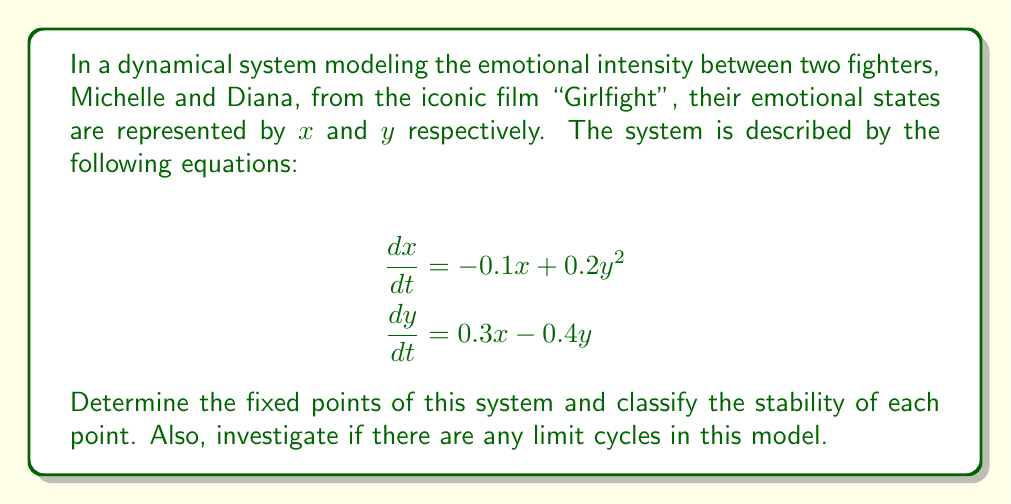Could you help me with this problem? Step 1: Find the fixed points
To find the fixed points, set both equations equal to zero:

$$-0.1x + 0.2y^2 = 0$$
$$0.3x - 0.4y = 0$$

From the second equation:
$$x = \frac{4y}{3}$$

Substituting this into the first equation:
$$-0.1(\frac{4y}{3}) + 0.2y^2 = 0$$
$$-\frac{4y}{30} + 0.2y^2 = 0$$
$$0.2y^2 - \frac{2y}{15} = 0$$
$$y(0.2y - \frac{2}{15}) = 0$$

Solving this, we get $y = 0$ or $y = \frac{1}{15}$

When $y = 0$, $x = 0$
When $y = \frac{1}{15}$, $x = \frac{4}{45}$

So, the fixed points are $(0,0)$ and $(\frac{4}{45}, \frac{1}{15})$

Step 2: Classify the stability of fixed points
To determine stability, we need to find the Jacobian matrix:

$$J = \begin{bmatrix}
\frac{\partial f_1}{\partial x} & \frac{\partial f_1}{\partial y} \\
\frac{\partial f_2}{\partial x} & \frac{\partial f_2}{\partial y}
\end{bmatrix} = \begin{bmatrix}
-0.1 & 0.4y \\
0.3 & -0.4
\end{bmatrix}$$

For $(0,0)$:
$$J_{(0,0)} = \begin{bmatrix}
-0.1 & 0 \\
0.3 & -0.4
\end{bmatrix}$$

The eigenvalues are $\lambda_1 = -0.1$ and $\lambda_2 = -0.4$. Both are negative, so $(0,0)$ is a stable node.

For $(\frac{4}{45}, \frac{1}{15})$:
$$J_{(\frac{4}{45}, \frac{1}{15})} = \begin{bmatrix}
-0.1 & 0.4(\frac{1}{15}) \\
0.3 & -0.4
\end{bmatrix} = \begin{bmatrix}
-0.1 & \frac{2}{75} \\
0.3 & -0.4
\end{bmatrix}$$

The eigenvalues are complex conjugates with negative real parts, so $(\frac{4}{45}, \frac{1}{15})$ is a stable spiral point.

Step 3: Investigate limit cycles
To determine if there are any limit cycles, we can use the Bendixson-Dulac theorem. Let's calculate the divergence of the vector field:

$$\nabla \cdot F = \frac{\partial f_1}{\partial x} + \frac{\partial f_2}{\partial y} = -0.1 - 0.4 = -0.5$$

Since the divergence is always negative and doesn't change sign, there are no limit cycles in this system according to the Bendixson-Dulac theorem.
Answer: Fixed points: $(0,0)$ (stable node) and $(\frac{4}{45}, \frac{1}{15})$ (stable spiral). No limit cycles exist. 